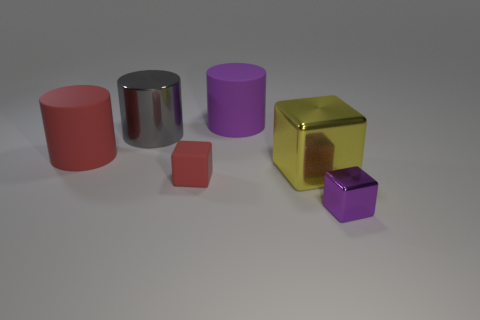Is the material of the object that is in front of the red cube the same as the tiny red object?
Offer a very short reply. No. There is a big matte thing that is on the right side of the tiny cube behind the tiny object that is on the right side of the red rubber cube; what shape is it?
Provide a short and direct response. Cylinder. There is another matte cylinder that is the same size as the purple rubber cylinder; what color is it?
Your answer should be very brief. Red. There is a large object that is both right of the tiny red block and behind the big metal cube; what is its material?
Give a very brief answer. Rubber. What shape is the thing that is the same color as the rubber block?
Your answer should be compact. Cylinder. Does the metal cylinder have the same size as the purple block?
Provide a short and direct response. No. There is a object in front of the tiny red matte object; what material is it?
Provide a succinct answer. Metal. What number of cylinders are to the right of the shiny thing right of the yellow metallic cube?
Your response must be concise. 0. Is there a big gray metallic object that has the same shape as the big purple matte thing?
Offer a very short reply. Yes. Does the purple thing in front of the yellow metal block have the same size as the rubber cylinder that is on the left side of the gray metallic thing?
Your response must be concise. No. 